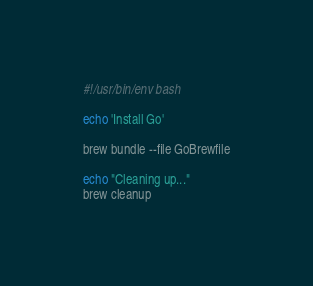<code> <loc_0><loc_0><loc_500><loc_500><_Bash_>#!/usr/bin/env bash

echo 'Install Go'

brew bundle --file GoBrewfile

echo "Cleaning up..."
brew cleanup</code> 